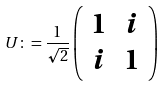<formula> <loc_0><loc_0><loc_500><loc_500>U \colon = \frac { 1 } { \sqrt { 2 } } \left ( \begin{array} { l l l } 1 & i \\ i & 1 \end{array} \right )</formula> 